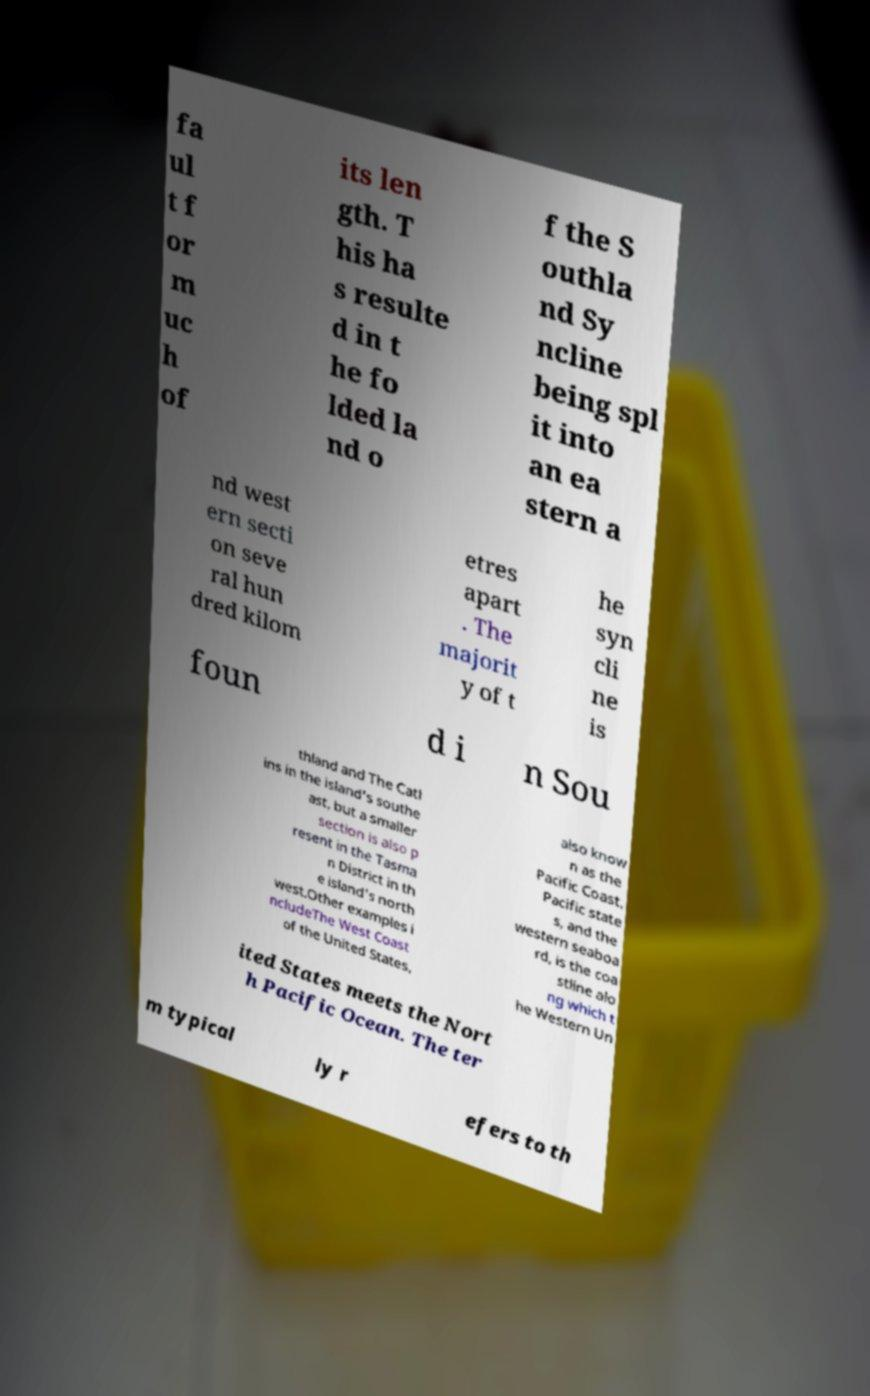Can you accurately transcribe the text from the provided image for me? fa ul t f or m uc h of its len gth. T his ha s resulte d in t he fo lded la nd o f the S outhla nd Sy ncline being spl it into an ea stern a nd west ern secti on seve ral hun dred kilom etres apart . The majorit y of t he syn cli ne is foun d i n Sou thland and The Catl ins in the island's southe ast, but a smaller section is also p resent in the Tasma n District in th e island's north west.Other examples i ncludeThe West Coast of the United States, also know n as the Pacific Coast, Pacific state s, and the western seaboa rd, is the coa stline alo ng which t he Western Un ited States meets the Nort h Pacific Ocean. The ter m typical ly r efers to th 